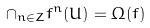<formula> <loc_0><loc_0><loc_500><loc_500>\cap _ { n \in Z } f ^ { n } ( U ) = \Omega ( f )</formula> 